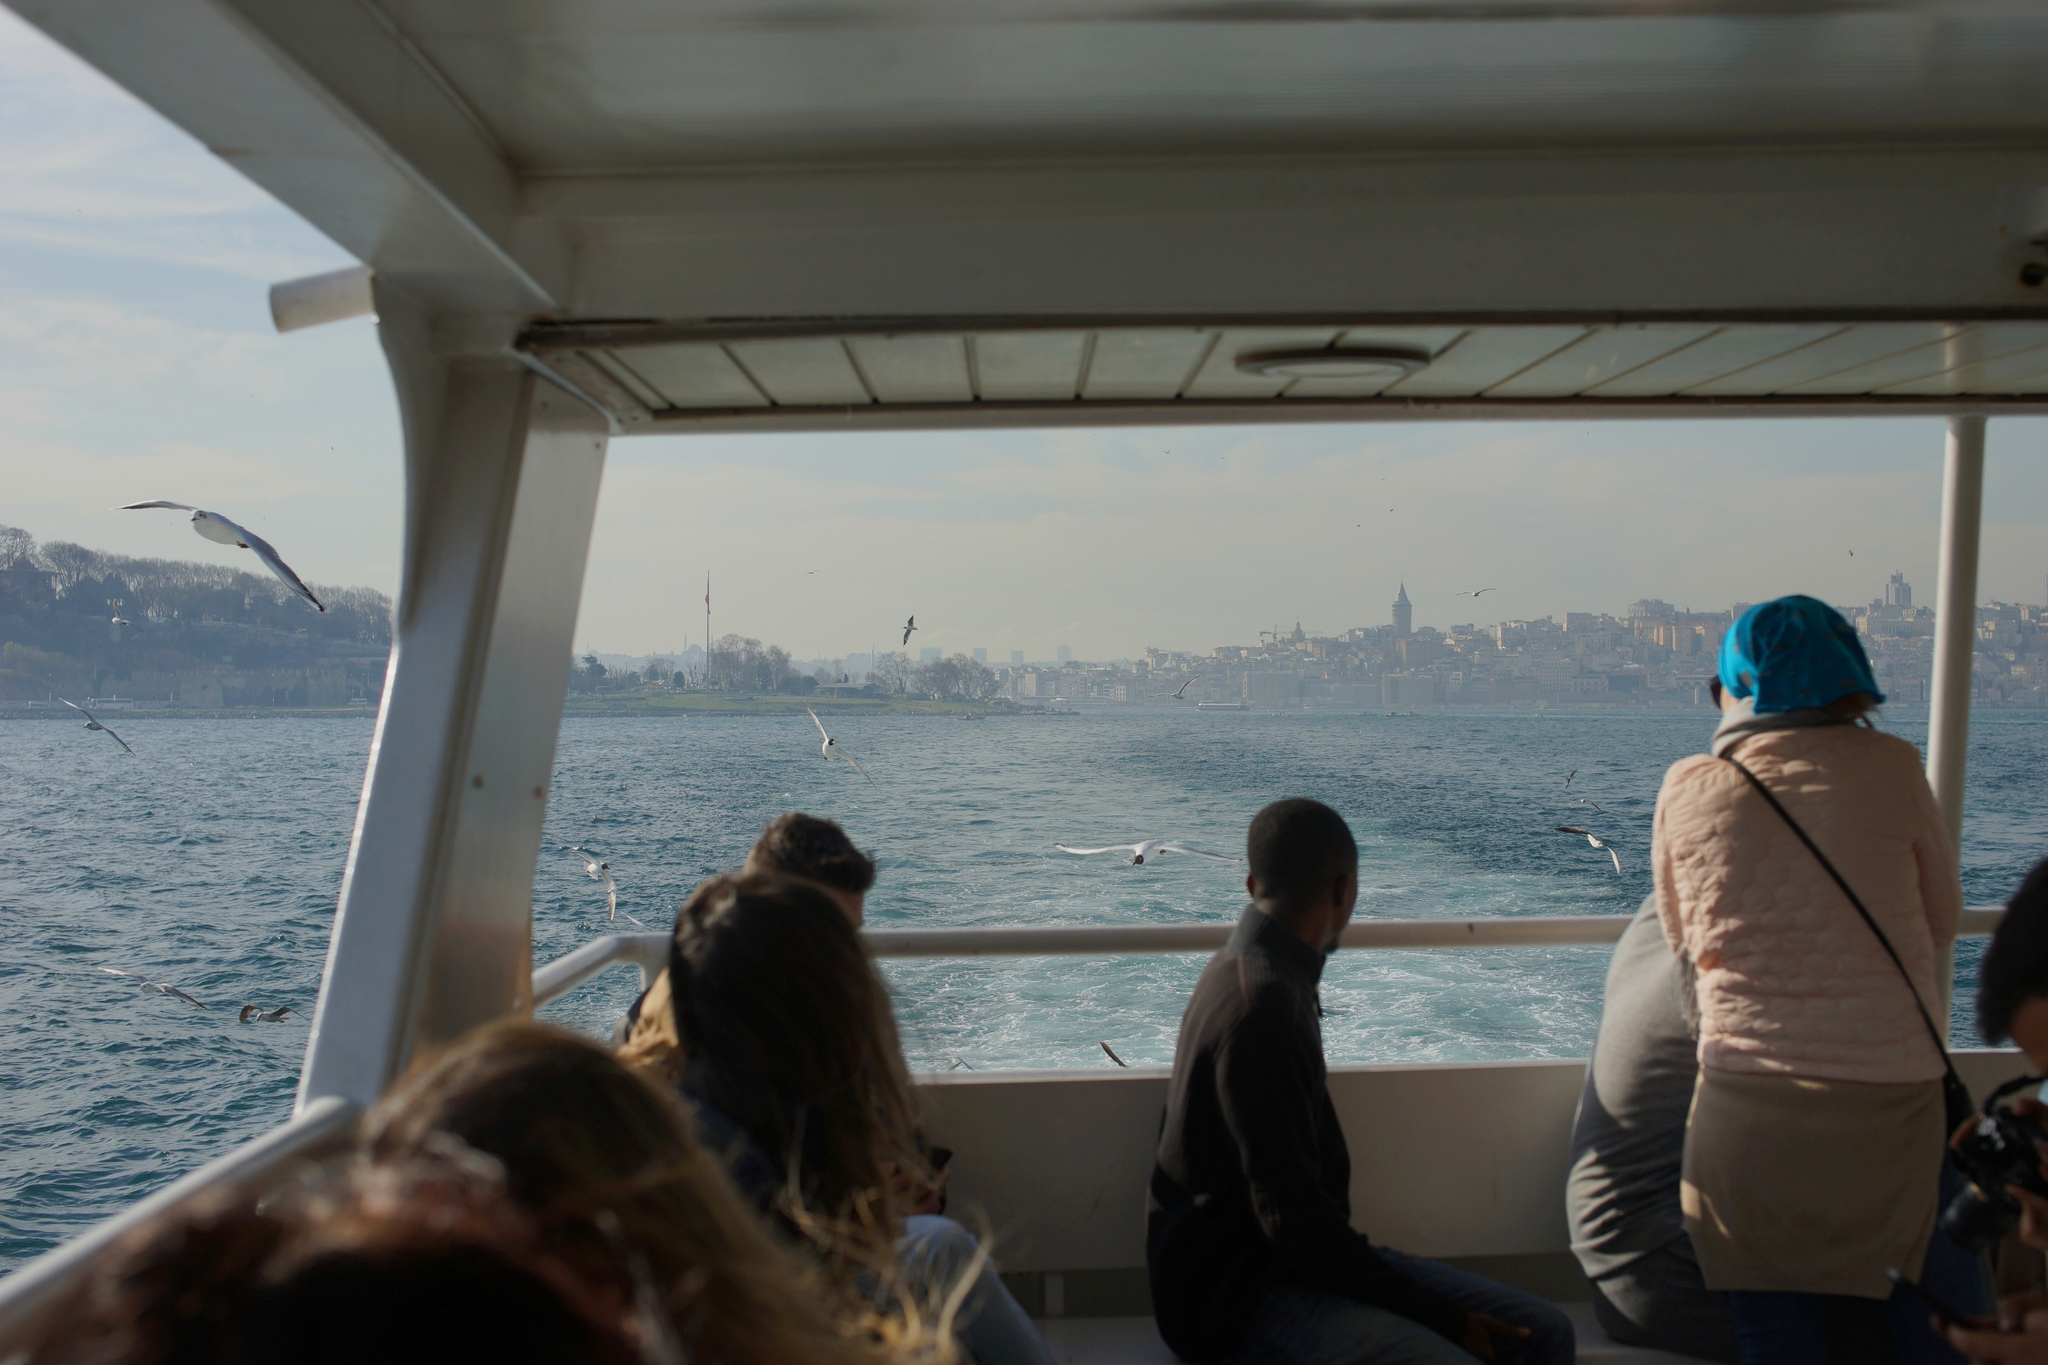What are the key elements in this picture? The picture centers on a busy yet serene boat ride with travelers gazing at the captivating city skyline in the distance. The skyline blends both modern and historical architectural elements, prominently featuring a noteworthy minaret, indicative of a location rich in cultural history. The calm, deep blue sea creates a tranquil contrast against the urban backdrop, and seagulls soar gracefully overhead, adding a touch of the natural world to the scene. The white boat, equipped with a covered seating area and protective railing, suggests it is intended for relaxing cruises or sightseeing tours. The people aboard the boat are dressed casually, pointing to either tourists or local citizens enjoying a leisurely day out. Some passengers capture the moment with their cameras, likely to share their experiences or preserve their memories. Although the exact landmark is not identifiable, the minaret and architectural style hint at a city where tradition and modernity coexist harmoniously. The code 'sa_15431' remains unexplained, potentially unique to the image's origin. 